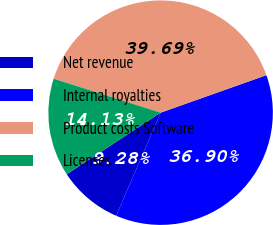Convert chart to OTSL. <chart><loc_0><loc_0><loc_500><loc_500><pie_chart><fcel>Net revenue<fcel>Internal royalties<fcel>Product costs Software<fcel>Licenses<nl><fcel>9.28%<fcel>36.9%<fcel>39.69%<fcel>14.13%<nl></chart> 